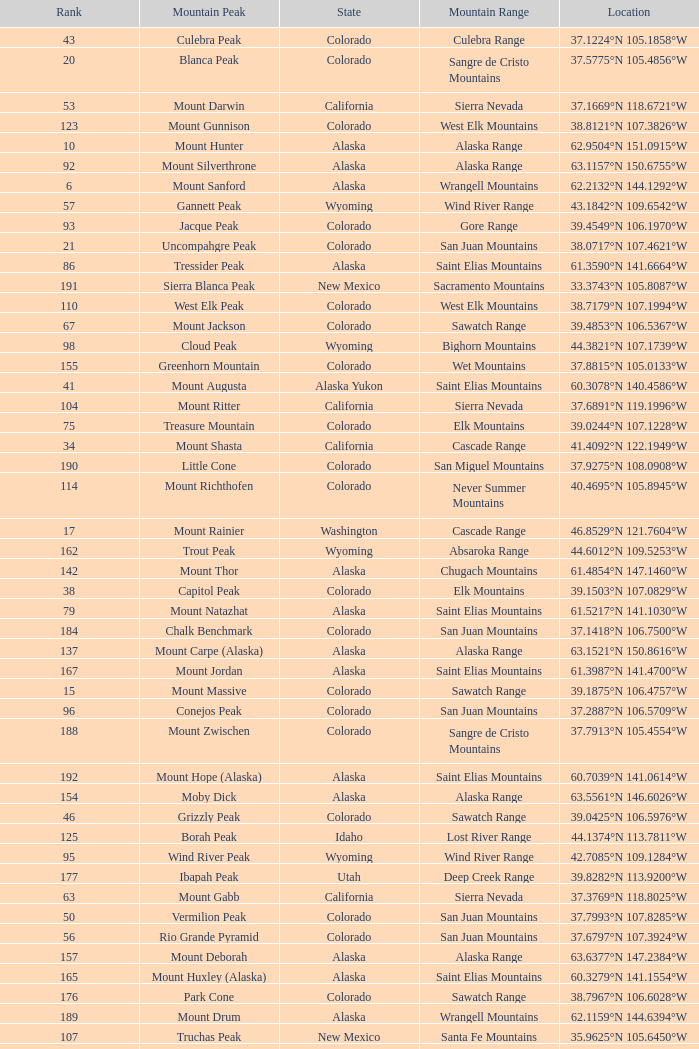What is the rank when the state is colorado and the location is 37.7859°n 107.7039°w? 83.0. 